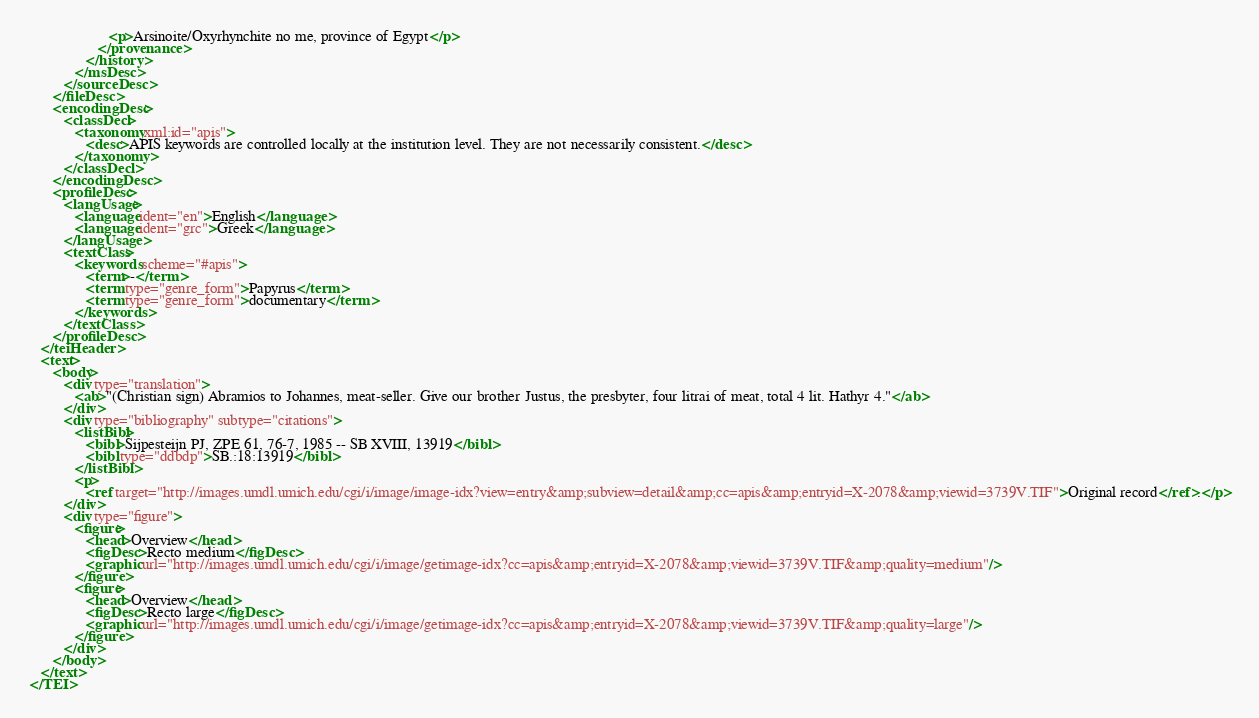Convert code to text. <code><loc_0><loc_0><loc_500><loc_500><_XML_>                     <p>Arsinoite/Oxyrhynchite no me, province of Egypt</p>
                  </provenance>
               </history>
            </msDesc>
         </sourceDesc>
      </fileDesc>
      <encodingDesc>
         <classDecl>
            <taxonomy xml:id="apis">
               <desc>APIS keywords are controlled locally at the institution level. They are not necessarily consistent.</desc>
            </taxonomy>
         </classDecl>
      </encodingDesc>
      <profileDesc>
         <langUsage>
            <language ident="en">English</language>
            <language ident="grc">Greek</language>
         </langUsage>
         <textClass>
            <keywords scheme="#apis">
               <term>-</term>
               <term type="genre_form">Papyrus</term>
               <term type="genre_form">documentary</term>
            </keywords>
         </textClass>
      </profileDesc>
   </teiHeader>
   <text>
      <body>
         <div type="translation">
            <ab>"(Christian sign) Abramios to Johannes, meat-seller. Give our brother Justus, the presbyter, four litrai of meat, total 4 lit. Hathyr 4."</ab>
         </div>
         <div type="bibliography" subtype="citations">
            <listBibl>
               <bibl>Sijpesteijn PJ, ZPE 61, 76-7, 1985 -- SB XVIII, 13919</bibl>
               <bibl type="ddbdp">SB.:18:13919</bibl>
            </listBibl>
            <p>
               <ref target="http://images.umdl.umich.edu/cgi/i/image/image-idx?view=entry&amp;subview=detail&amp;cc=apis&amp;entryid=X-2078&amp;viewid=3739V.TIF">Original record</ref>.</p>
         </div>
         <div type="figure">
            <figure>
               <head>Overview</head>
               <figDesc>Recto medium</figDesc>
               <graphic url="http://images.umdl.umich.edu/cgi/i/image/getimage-idx?cc=apis&amp;entryid=X-2078&amp;viewid=3739V.TIF&amp;quality=medium"/>
            </figure>
            <figure>
               <head>Overview</head>
               <figDesc>Recto large</figDesc>
               <graphic url="http://images.umdl.umich.edu/cgi/i/image/getimage-idx?cc=apis&amp;entryid=X-2078&amp;viewid=3739V.TIF&amp;quality=large"/>
            </figure>
         </div>
      </body>
   </text>
</TEI>
</code> 